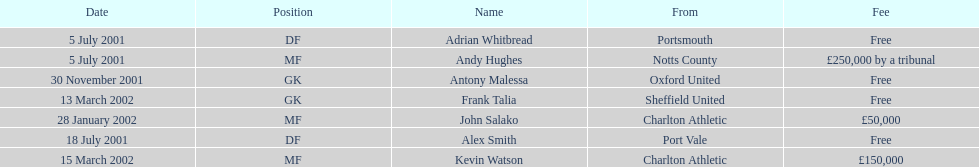After november 30, 2001, who moved or changed their location? John Salako, Frank Talia, Kevin Watson. 